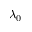Convert formula to latex. <formula><loc_0><loc_0><loc_500><loc_500>\lambda _ { 0 }</formula> 